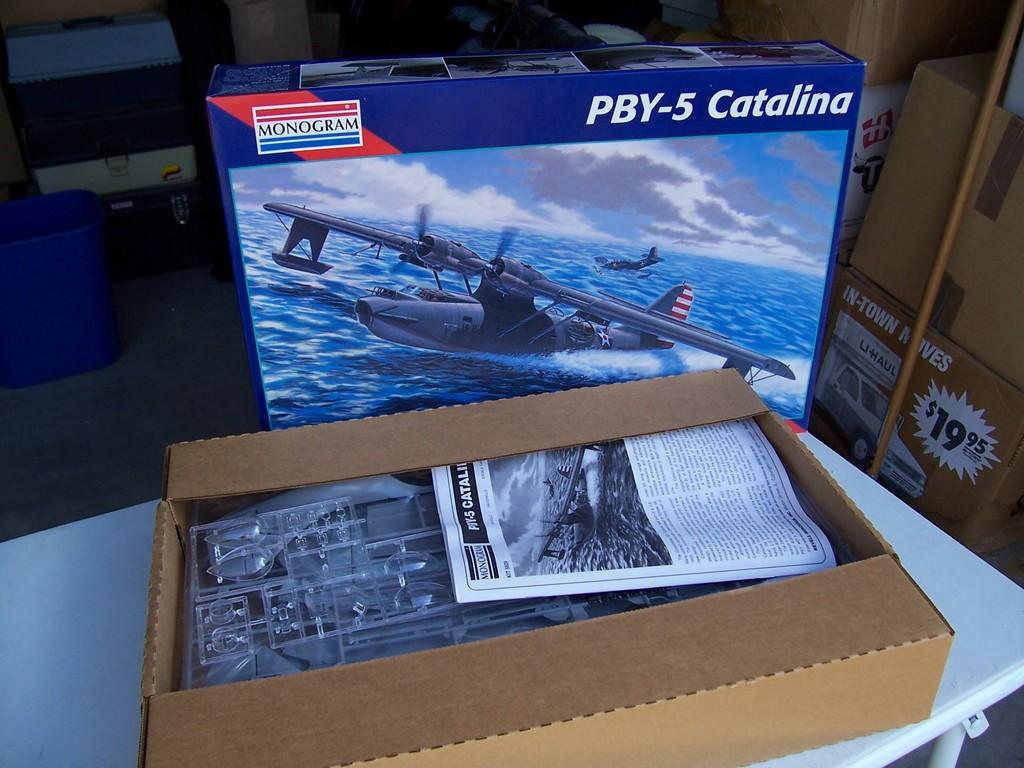<image>
Create a compact narrative representing the image presented. Box of PBY-5 Catalina with a monogram logo on it. 